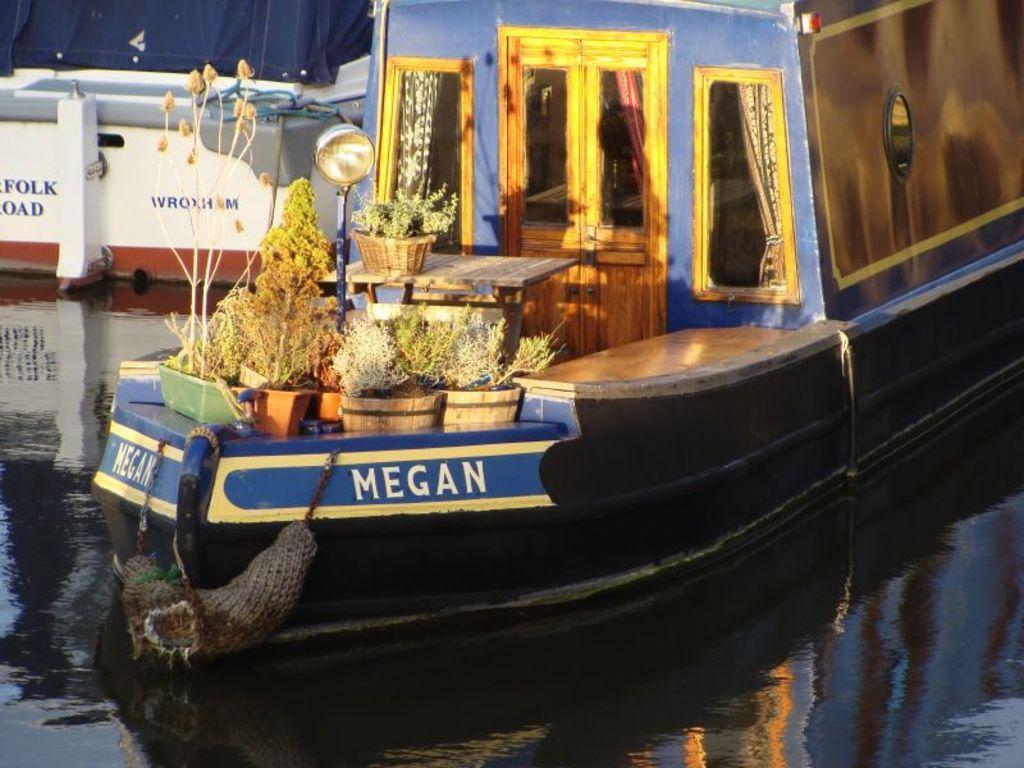How would you summarize this image in a sentence or two? In this image, we can see a ship with some objects like flower pots, tables and a pole sailing on the water. We can also see a white colored object. 